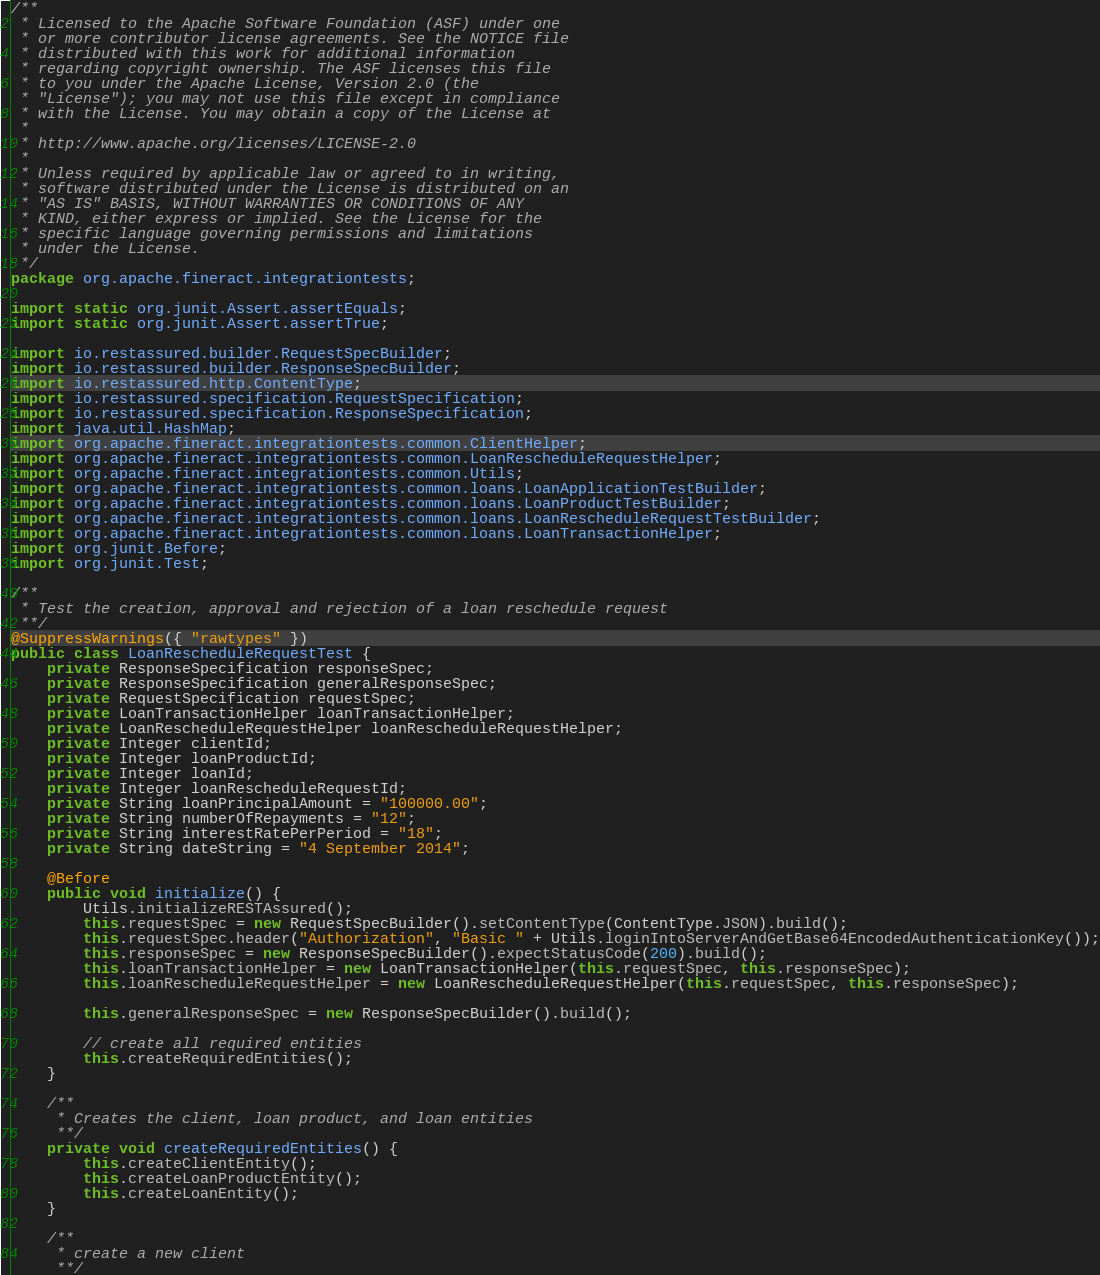<code> <loc_0><loc_0><loc_500><loc_500><_Java_>/**
 * Licensed to the Apache Software Foundation (ASF) under one
 * or more contributor license agreements. See the NOTICE file
 * distributed with this work for additional information
 * regarding copyright ownership. The ASF licenses this file
 * to you under the Apache License, Version 2.0 (the
 * "License"); you may not use this file except in compliance
 * with the License. You may obtain a copy of the License at
 *
 * http://www.apache.org/licenses/LICENSE-2.0
 *
 * Unless required by applicable law or agreed to in writing,
 * software distributed under the License is distributed on an
 * "AS IS" BASIS, WITHOUT WARRANTIES OR CONDITIONS OF ANY
 * KIND, either express or implied. See the License for the
 * specific language governing permissions and limitations
 * under the License.
 */
package org.apache.fineract.integrationtests;

import static org.junit.Assert.assertEquals;
import static org.junit.Assert.assertTrue;

import io.restassured.builder.RequestSpecBuilder;
import io.restassured.builder.ResponseSpecBuilder;
import io.restassured.http.ContentType;
import io.restassured.specification.RequestSpecification;
import io.restassured.specification.ResponseSpecification;
import java.util.HashMap;
import org.apache.fineract.integrationtests.common.ClientHelper;
import org.apache.fineract.integrationtests.common.LoanRescheduleRequestHelper;
import org.apache.fineract.integrationtests.common.Utils;
import org.apache.fineract.integrationtests.common.loans.LoanApplicationTestBuilder;
import org.apache.fineract.integrationtests.common.loans.LoanProductTestBuilder;
import org.apache.fineract.integrationtests.common.loans.LoanRescheduleRequestTestBuilder;
import org.apache.fineract.integrationtests.common.loans.LoanTransactionHelper;
import org.junit.Before;
import org.junit.Test;

/**
 * Test the creation, approval and rejection of a loan reschedule request
 **/
@SuppressWarnings({ "rawtypes" })
public class LoanRescheduleRequestTest {
    private ResponseSpecification responseSpec;
    private ResponseSpecification generalResponseSpec;
    private RequestSpecification requestSpec;
    private LoanTransactionHelper loanTransactionHelper;
    private LoanRescheduleRequestHelper loanRescheduleRequestHelper;
    private Integer clientId;
    private Integer loanProductId;
    private Integer loanId;
    private Integer loanRescheduleRequestId;
    private String loanPrincipalAmount = "100000.00";
    private String numberOfRepayments = "12";
    private String interestRatePerPeriod = "18";
    private String dateString = "4 September 2014";

    @Before
    public void initialize() {
        Utils.initializeRESTAssured();
        this.requestSpec = new RequestSpecBuilder().setContentType(ContentType.JSON).build();
        this.requestSpec.header("Authorization", "Basic " + Utils.loginIntoServerAndGetBase64EncodedAuthenticationKey());
        this.responseSpec = new ResponseSpecBuilder().expectStatusCode(200).build();
        this.loanTransactionHelper = new LoanTransactionHelper(this.requestSpec, this.responseSpec);
        this.loanRescheduleRequestHelper = new LoanRescheduleRequestHelper(this.requestSpec, this.responseSpec);

        this.generalResponseSpec = new ResponseSpecBuilder().build();

        // create all required entities
        this.createRequiredEntities();
    }

    /**
     * Creates the client, loan product, and loan entities
     **/
    private void createRequiredEntities() {
        this.createClientEntity();
        this.createLoanProductEntity();
        this.createLoanEntity();
    }

    /**
     * create a new client
     **/</code> 